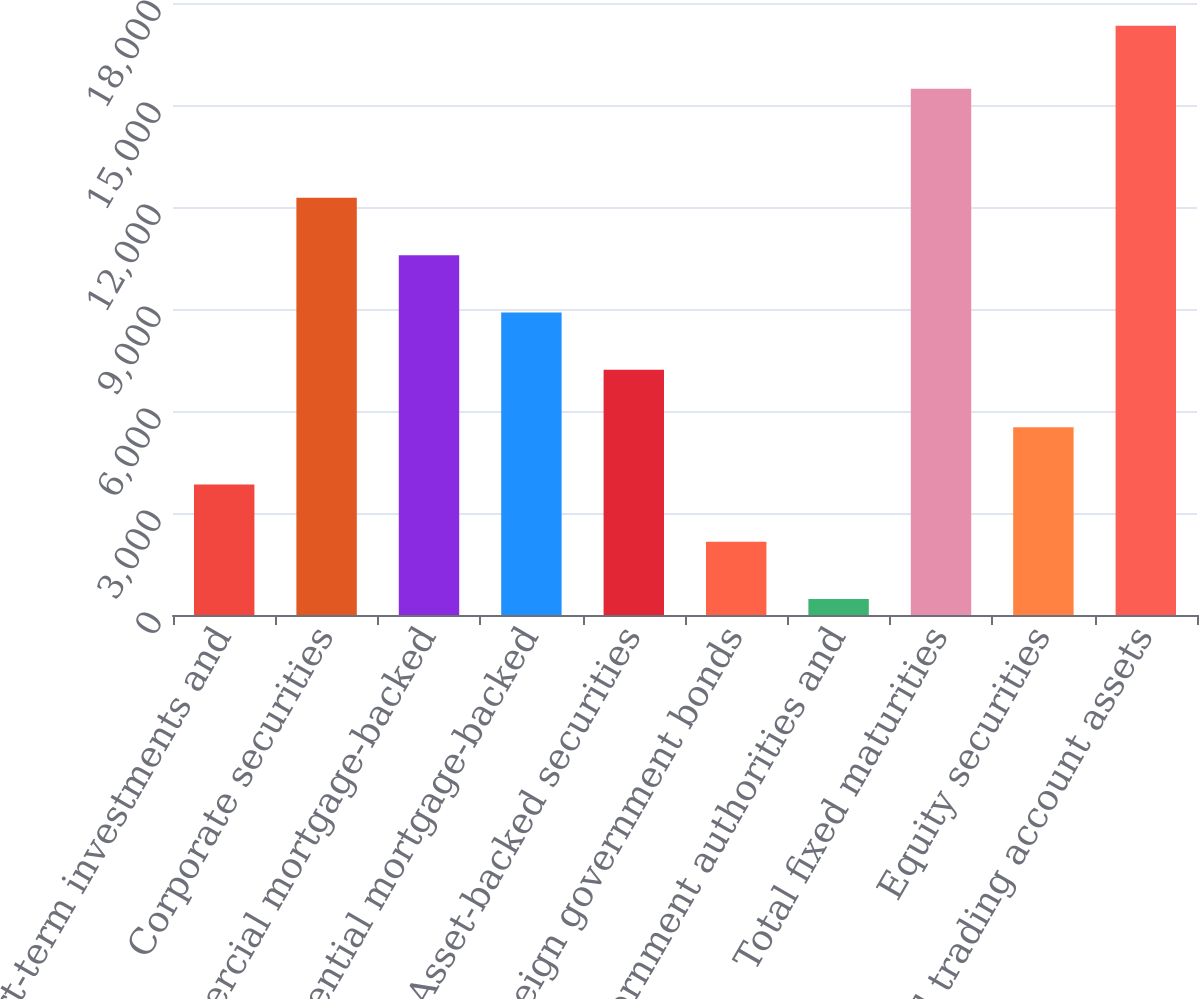Convert chart. <chart><loc_0><loc_0><loc_500><loc_500><bar_chart><fcel>Short-term investments and<fcel>Corporate securities<fcel>Commercial mortgage-backed<fcel>Residential mortgage-backed<fcel>Asset-backed securities<fcel>Foreign government bonds<fcel>US government authorities and<fcel>Total fixed maturities<fcel>Equity securities<fcel>Total trading account assets<nl><fcel>3839.2<fcel>12269.7<fcel>10583.6<fcel>8897.5<fcel>7211.4<fcel>2153.1<fcel>467<fcel>15475<fcel>5525.3<fcel>17328<nl></chart> 